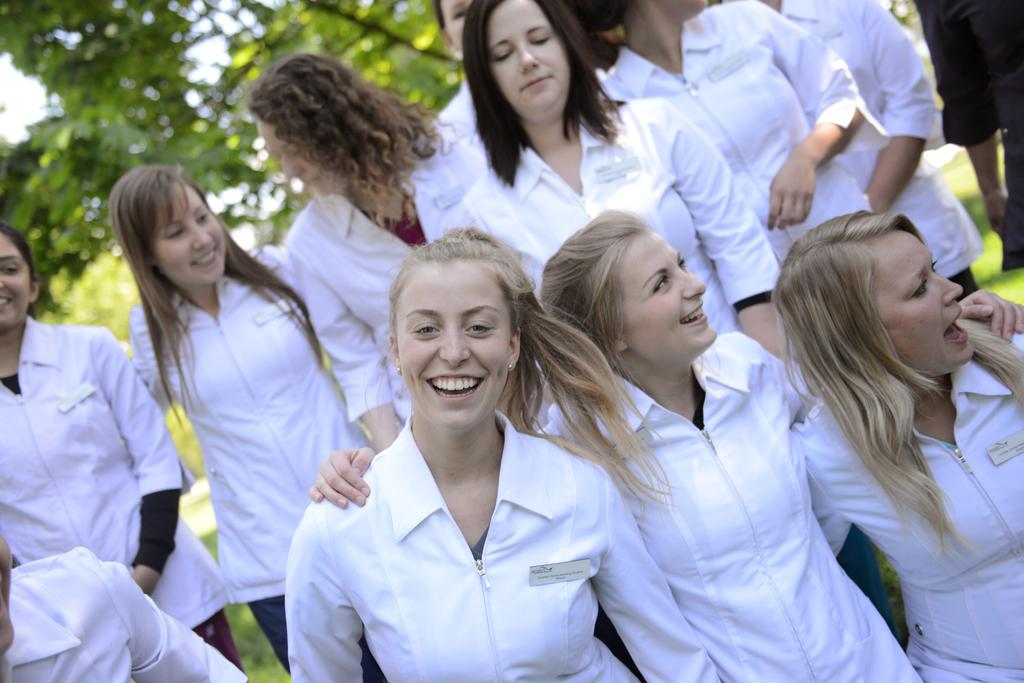Who is present in the image? There are women in the image. What are the women wearing? The women are wearing white jackets. What can be seen in the background of the image? There are trees in the background of the image. Where is the volcano located in the image? There is no volcano present in the image. What type of trucks can be seen in the image? There are no trucks present in the image. 